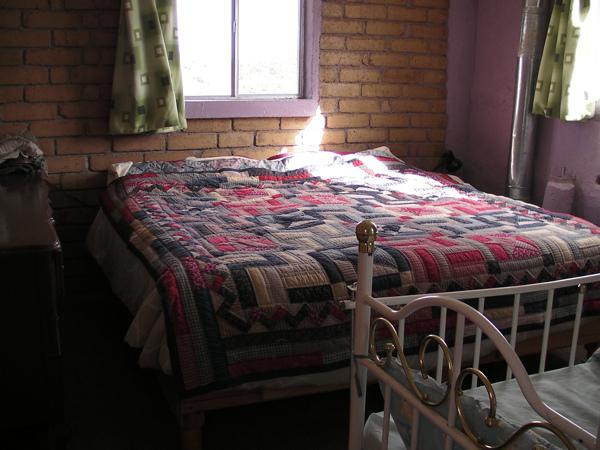What type of material is the bed frame made from?
Concise answer only. Metal. How old is this blanket?
Quick response, please. Old. What color is the blanket?
Short answer required. Multi colors. 